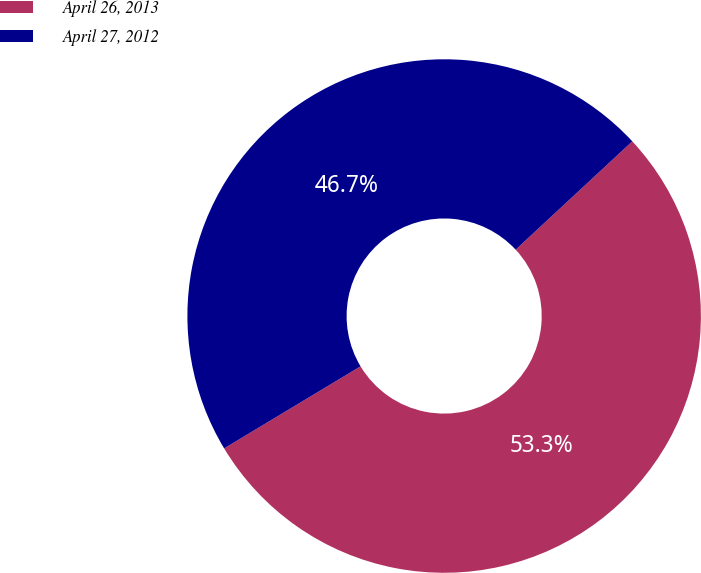Convert chart. <chart><loc_0><loc_0><loc_500><loc_500><pie_chart><fcel>April 26, 2013<fcel>April 27, 2012<nl><fcel>53.29%<fcel>46.71%<nl></chart> 